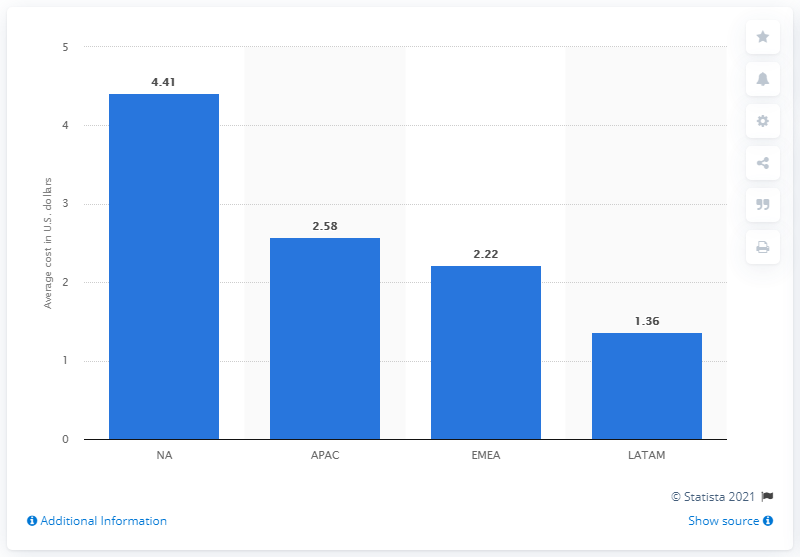Identify some key points in this picture. The average cost-to-install for a mobile shopping app in the APAC region was 2.58. 